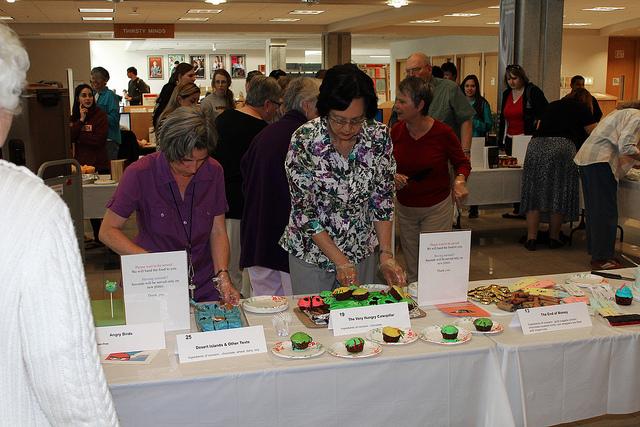What food is on the center of the table?
Write a very short answer. Cupcakes. What kind of cupcakes are on the table?
Write a very short answer. Chocolate. What color shirt is the woman on the left wearing?
Quick response, please. Purple. What type of scene is this?
Keep it brief. Party. Is this a restaurant cooking area?
Concise answer only. No. 